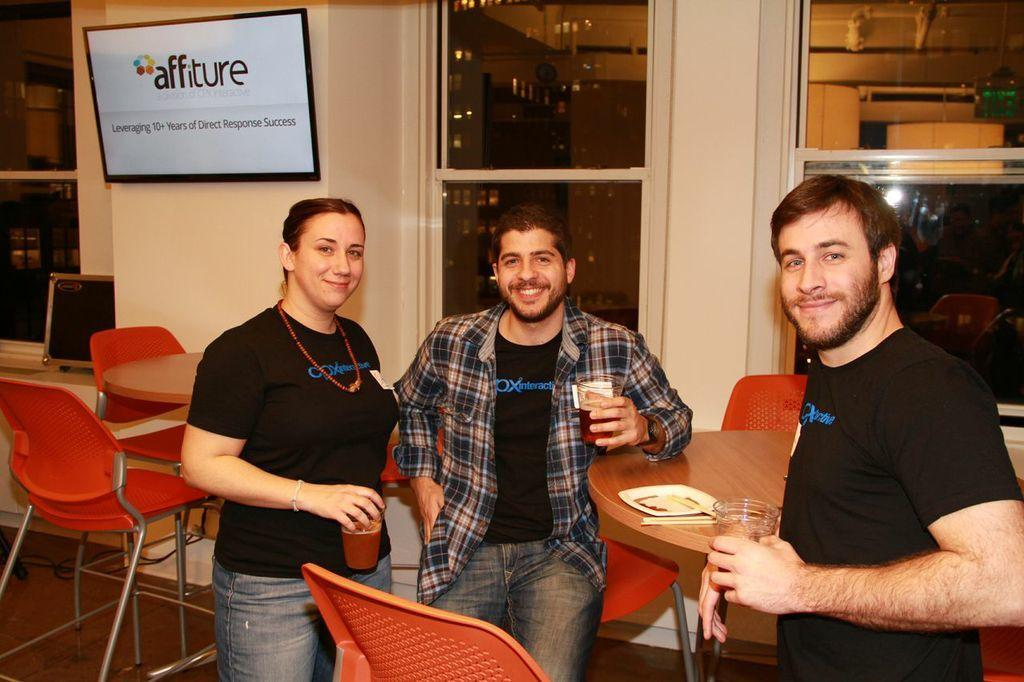How many people are present in the image? There are three people in the image. What are the people holding in their hands? The people are holding glasses. What is separating the people in the image? There is a table between the people. What can be seen on the screen in the image? The facts provided do not mention any details about the screen, so we cannot determine what is visible on it. What type of turkey is visible on the table in the image? There is no turkey present in the image. 